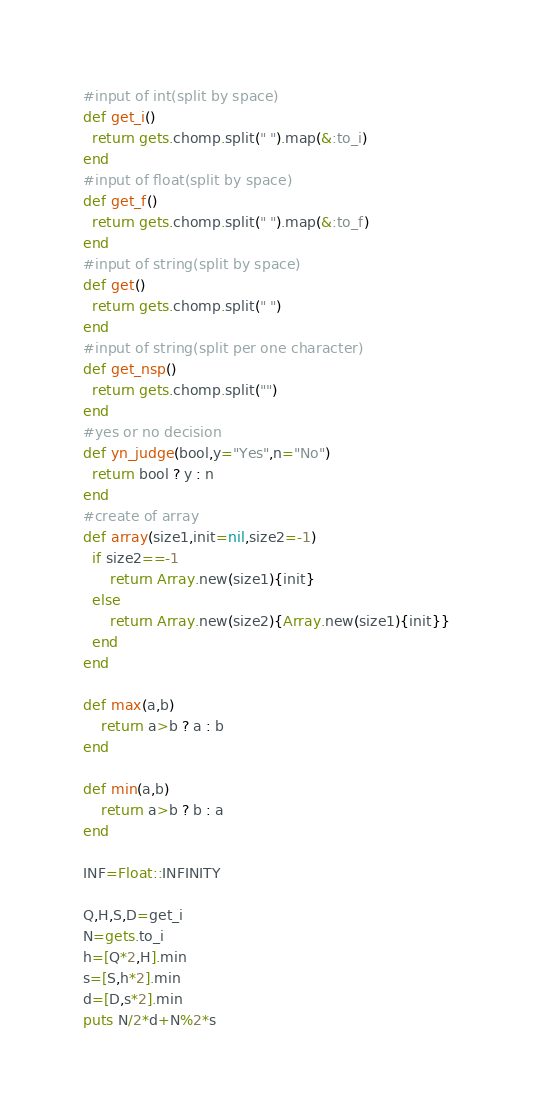<code> <loc_0><loc_0><loc_500><loc_500><_Ruby_>#input of int(split by space)
def get_i()
  return gets.chomp.split(" ").map(&:to_i)
end
#input of float(split by space)
def get_f()
  return gets.chomp.split(" ").map(&:to_f)
end
#input of string(split by space)
def get()
  return gets.chomp.split(" ")
end
#input of string(split per one character)
def get_nsp()
  return gets.chomp.split("")
end
#yes or no decision
def yn_judge(bool,y="Yes",n="No")
  return bool ? y : n 
end
#create of array
def array(size1,init=nil,size2=-1)
  if size2==-1
      return Array.new(size1){init}
  else
      return Array.new(size2){Array.new(size1){init}}
  end
end

def max(a,b)
    return a>b ? a : b
end

def min(a,b)
    return a>b ? b : a
end

INF=Float::INFINITY

Q,H,S,D=get_i
N=gets.to_i
h=[Q*2,H].min
s=[S,h*2].min
d=[D,s*2].min
puts N/2*d+N%2*s</code> 